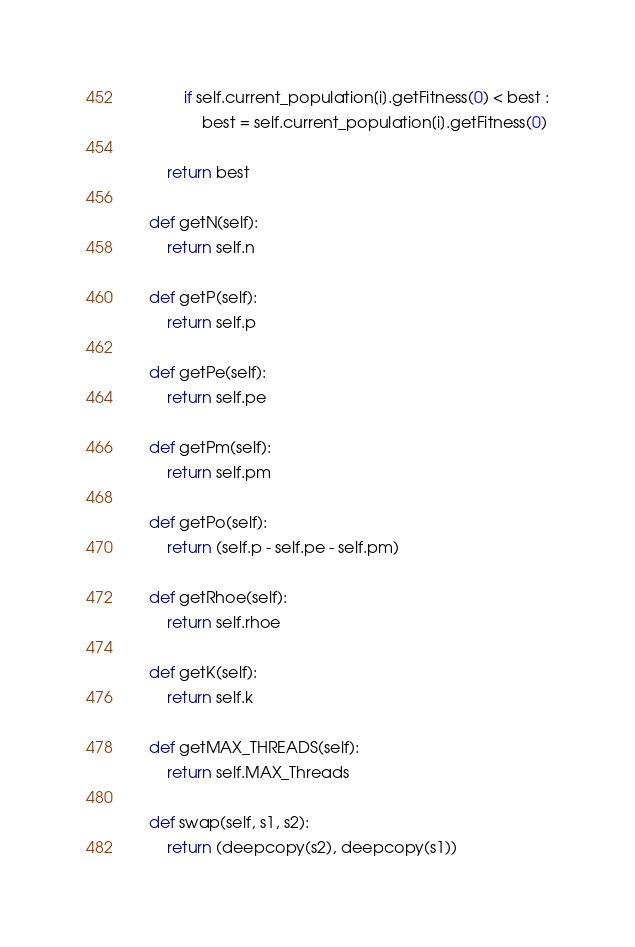<code> <loc_0><loc_0><loc_500><loc_500><_Python_>            if self.current_population[i].getFitness(0) < best :
                best = self.current_population[i].getFitness(0)

        return best 

    def getN(self):
        return self.n

    def getP(self):
        return self.p

    def getPe(self):
        return self.pe

    def getPm(self):
        return self.pm

    def getPo(self):
        return (self.p - self.pe - self.pm)

    def getRhoe(self):
        return self.rhoe

    def getK(self):
        return self.k

    def getMAX_THREADS(self):
        return self.MAX_Threads     
        
    def swap(self, s1, s2):
        return (deepcopy(s2), deepcopy(s1))
</code> 